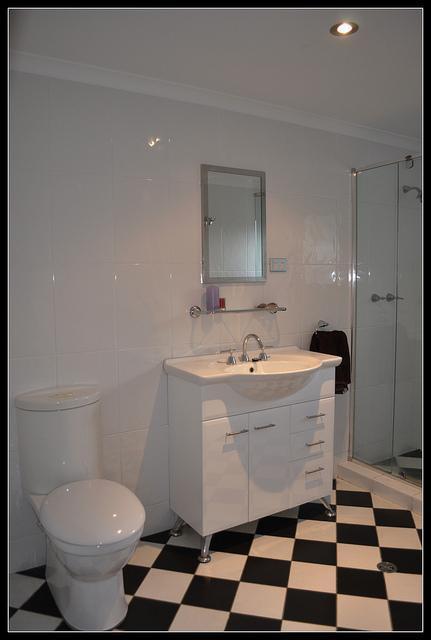How many televisions are in this room?
Give a very brief answer. 0. How many sinks are there?
Give a very brief answer. 1. How many rooms do you see?
Give a very brief answer. 1. How many toilets are there?
Give a very brief answer. 1. How many rolls of toilet paper are visible?
Give a very brief answer. 0. How many sinks are in the picture?
Give a very brief answer. 2. 